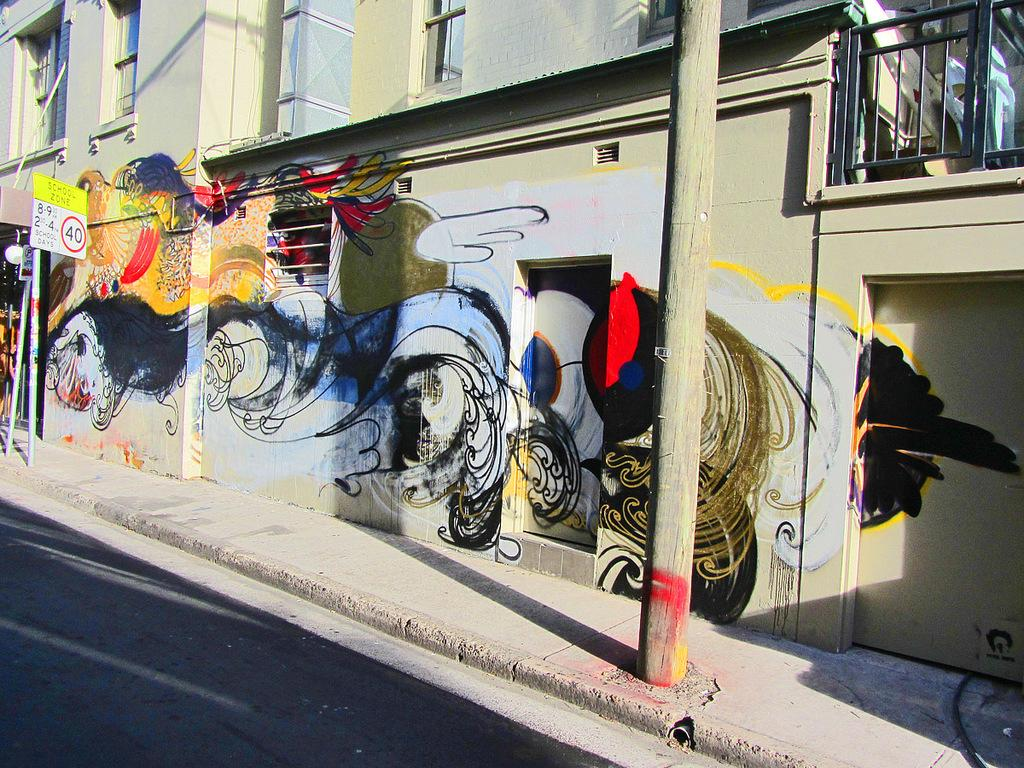What is the main feature of the image? There is a road in the image. What else can be seen along the road? There are poles in the image. Is there any text visible in the image? Yes, there is a board with text in the image. What can be seen in the background of the image? There is a painting on a building in the background of the image. How much oil is used in the painting on the building in the image? There is no information about the painting's medium or materials in the image, so we cannot determine the amount of oil used. 